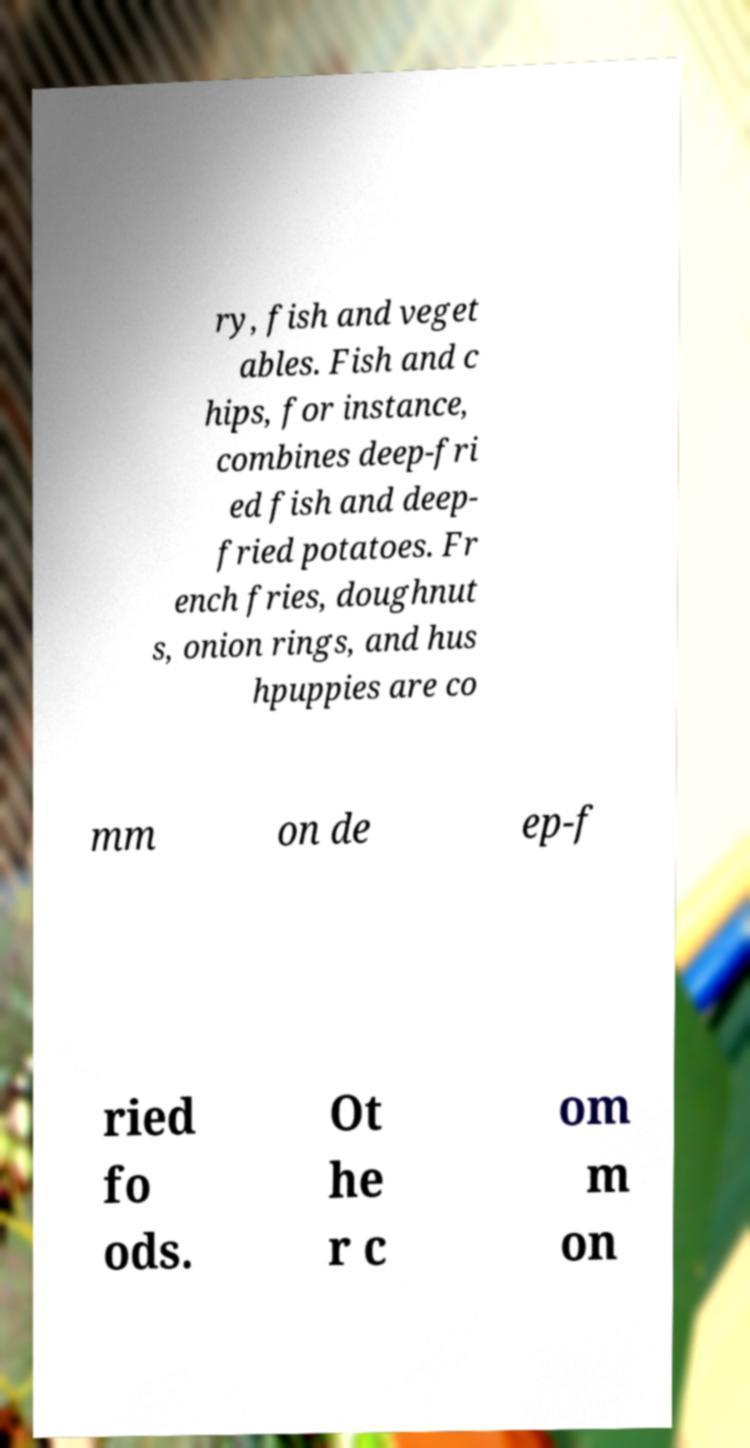Could you assist in decoding the text presented in this image and type it out clearly? ry, fish and veget ables. Fish and c hips, for instance, combines deep-fri ed fish and deep- fried potatoes. Fr ench fries, doughnut s, onion rings, and hus hpuppies are co mm on de ep-f ried fo ods. Ot he r c om m on 